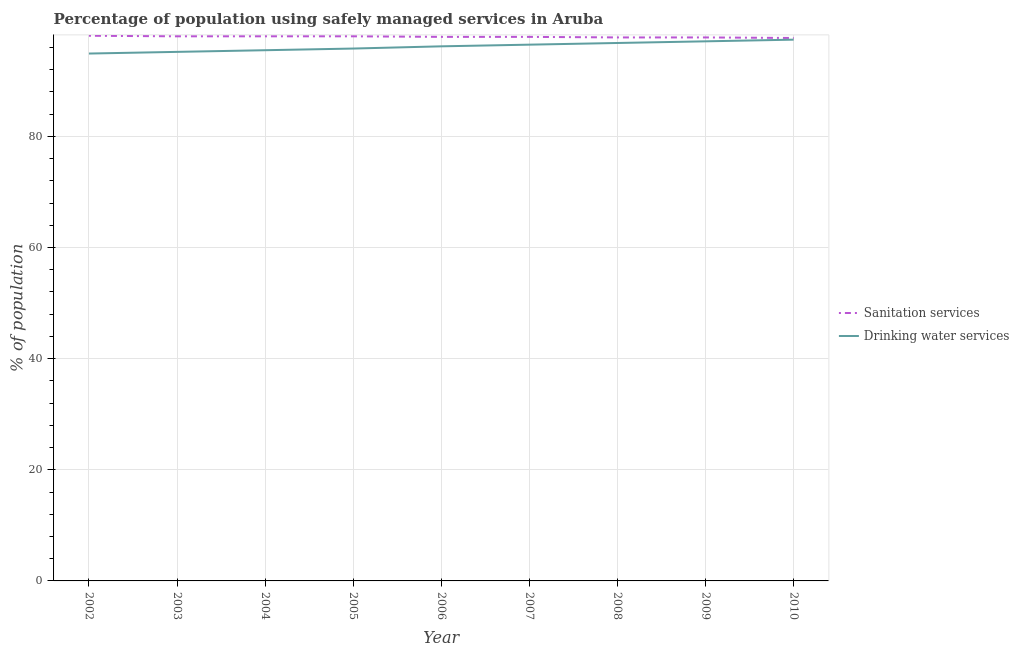How many different coloured lines are there?
Keep it short and to the point. 2. Does the line corresponding to percentage of population who used drinking water services intersect with the line corresponding to percentage of population who used sanitation services?
Your answer should be very brief. No. What is the percentage of population who used drinking water services in 2005?
Keep it short and to the point. 95.8. Across all years, what is the maximum percentage of population who used drinking water services?
Provide a succinct answer. 97.4. Across all years, what is the minimum percentage of population who used sanitation services?
Make the answer very short. 97.7. What is the total percentage of population who used sanitation services in the graph?
Your response must be concise. 881.2. What is the difference between the percentage of population who used sanitation services in 2004 and that in 2005?
Your answer should be compact. 0. What is the difference between the percentage of population who used sanitation services in 2002 and the percentage of population who used drinking water services in 2010?
Your response must be concise. 0.7. What is the average percentage of population who used drinking water services per year?
Your answer should be compact. 96.16. In the year 2007, what is the difference between the percentage of population who used drinking water services and percentage of population who used sanitation services?
Provide a succinct answer. -1.4. In how many years, is the percentage of population who used drinking water services greater than 8 %?
Your answer should be compact. 9. What is the ratio of the percentage of population who used sanitation services in 2002 to that in 2007?
Provide a succinct answer. 1. Is the percentage of population who used sanitation services in 2004 less than that in 2010?
Provide a short and direct response. No. Is the difference between the percentage of population who used drinking water services in 2003 and 2009 greater than the difference between the percentage of population who used sanitation services in 2003 and 2009?
Offer a very short reply. No. What is the difference between the highest and the second highest percentage of population who used sanitation services?
Give a very brief answer. 0.1. What is the difference between the highest and the lowest percentage of population who used drinking water services?
Provide a short and direct response. 2.5. Is the sum of the percentage of population who used drinking water services in 2005 and 2007 greater than the maximum percentage of population who used sanitation services across all years?
Offer a very short reply. Yes. Is the percentage of population who used drinking water services strictly greater than the percentage of population who used sanitation services over the years?
Provide a short and direct response. No. Is the percentage of population who used sanitation services strictly less than the percentage of population who used drinking water services over the years?
Provide a short and direct response. No. How many lines are there?
Your answer should be very brief. 2. How many years are there in the graph?
Your answer should be compact. 9. Does the graph contain grids?
Keep it short and to the point. Yes. Where does the legend appear in the graph?
Ensure brevity in your answer.  Center right. How many legend labels are there?
Your response must be concise. 2. What is the title of the graph?
Provide a short and direct response. Percentage of population using safely managed services in Aruba. Does "Urban" appear as one of the legend labels in the graph?
Give a very brief answer. No. What is the label or title of the Y-axis?
Provide a succinct answer. % of population. What is the % of population of Sanitation services in 2002?
Your answer should be compact. 98.1. What is the % of population in Drinking water services in 2002?
Your response must be concise. 94.9. What is the % of population in Sanitation services in 2003?
Give a very brief answer. 98. What is the % of population of Drinking water services in 2003?
Provide a short and direct response. 95.2. What is the % of population of Drinking water services in 2004?
Provide a succinct answer. 95.5. What is the % of population of Sanitation services in 2005?
Keep it short and to the point. 98. What is the % of population in Drinking water services in 2005?
Ensure brevity in your answer.  95.8. What is the % of population in Sanitation services in 2006?
Keep it short and to the point. 97.9. What is the % of population of Drinking water services in 2006?
Your response must be concise. 96.2. What is the % of population in Sanitation services in 2007?
Give a very brief answer. 97.9. What is the % of population of Drinking water services in 2007?
Offer a very short reply. 96.5. What is the % of population in Sanitation services in 2008?
Keep it short and to the point. 97.8. What is the % of population in Drinking water services in 2008?
Keep it short and to the point. 96.8. What is the % of population of Sanitation services in 2009?
Offer a very short reply. 97.8. What is the % of population in Drinking water services in 2009?
Offer a very short reply. 97.1. What is the % of population in Sanitation services in 2010?
Your answer should be compact. 97.7. What is the % of population of Drinking water services in 2010?
Provide a short and direct response. 97.4. Across all years, what is the maximum % of population of Sanitation services?
Give a very brief answer. 98.1. Across all years, what is the maximum % of population in Drinking water services?
Your answer should be compact. 97.4. Across all years, what is the minimum % of population of Sanitation services?
Your answer should be very brief. 97.7. Across all years, what is the minimum % of population in Drinking water services?
Keep it short and to the point. 94.9. What is the total % of population in Sanitation services in the graph?
Provide a succinct answer. 881.2. What is the total % of population of Drinking water services in the graph?
Offer a very short reply. 865.4. What is the difference between the % of population in Sanitation services in 2002 and that in 2003?
Offer a terse response. 0.1. What is the difference between the % of population of Drinking water services in 2002 and that in 2005?
Ensure brevity in your answer.  -0.9. What is the difference between the % of population of Drinking water services in 2002 and that in 2006?
Provide a succinct answer. -1.3. What is the difference between the % of population of Drinking water services in 2002 and that in 2007?
Provide a succinct answer. -1.6. What is the difference between the % of population in Sanitation services in 2002 and that in 2008?
Give a very brief answer. 0.3. What is the difference between the % of population in Drinking water services in 2002 and that in 2009?
Your answer should be compact. -2.2. What is the difference between the % of population of Drinking water services in 2002 and that in 2010?
Your answer should be very brief. -2.5. What is the difference between the % of population of Drinking water services in 2003 and that in 2006?
Provide a succinct answer. -1. What is the difference between the % of population of Sanitation services in 2003 and that in 2007?
Provide a short and direct response. 0.1. What is the difference between the % of population in Drinking water services in 2003 and that in 2007?
Your answer should be very brief. -1.3. What is the difference between the % of population in Drinking water services in 2003 and that in 2008?
Make the answer very short. -1.6. What is the difference between the % of population in Drinking water services in 2003 and that in 2009?
Your answer should be very brief. -1.9. What is the difference between the % of population of Sanitation services in 2003 and that in 2010?
Make the answer very short. 0.3. What is the difference between the % of population of Drinking water services in 2003 and that in 2010?
Ensure brevity in your answer.  -2.2. What is the difference between the % of population of Drinking water services in 2004 and that in 2006?
Offer a very short reply. -0.7. What is the difference between the % of population of Sanitation services in 2004 and that in 2007?
Provide a short and direct response. 0.1. What is the difference between the % of population in Drinking water services in 2004 and that in 2007?
Keep it short and to the point. -1. What is the difference between the % of population of Sanitation services in 2004 and that in 2008?
Offer a very short reply. 0.2. What is the difference between the % of population of Sanitation services in 2004 and that in 2009?
Give a very brief answer. 0.2. What is the difference between the % of population in Sanitation services in 2004 and that in 2010?
Offer a terse response. 0.3. What is the difference between the % of population in Drinking water services in 2005 and that in 2007?
Keep it short and to the point. -0.7. What is the difference between the % of population of Sanitation services in 2005 and that in 2009?
Give a very brief answer. 0.2. What is the difference between the % of population of Drinking water services in 2006 and that in 2007?
Offer a terse response. -0.3. What is the difference between the % of population of Sanitation services in 2006 and that in 2009?
Make the answer very short. 0.1. What is the difference between the % of population in Drinking water services in 2006 and that in 2009?
Your response must be concise. -0.9. What is the difference between the % of population in Sanitation services in 2007 and that in 2008?
Keep it short and to the point. 0.1. What is the difference between the % of population of Sanitation services in 2007 and that in 2010?
Your response must be concise. 0.2. What is the difference between the % of population of Sanitation services in 2008 and that in 2010?
Your answer should be compact. 0.1. What is the difference between the % of population of Drinking water services in 2008 and that in 2010?
Offer a terse response. -0.6. What is the difference between the % of population of Sanitation services in 2002 and the % of population of Drinking water services in 2006?
Give a very brief answer. 1.9. What is the difference between the % of population in Sanitation services in 2002 and the % of population in Drinking water services in 2007?
Offer a terse response. 1.6. What is the difference between the % of population of Sanitation services in 2002 and the % of population of Drinking water services in 2008?
Offer a terse response. 1.3. What is the difference between the % of population of Sanitation services in 2002 and the % of population of Drinking water services in 2009?
Your answer should be compact. 1. What is the difference between the % of population of Sanitation services in 2002 and the % of population of Drinking water services in 2010?
Ensure brevity in your answer.  0.7. What is the difference between the % of population in Sanitation services in 2003 and the % of population in Drinking water services in 2004?
Your answer should be very brief. 2.5. What is the difference between the % of population of Sanitation services in 2003 and the % of population of Drinking water services in 2005?
Offer a very short reply. 2.2. What is the difference between the % of population in Sanitation services in 2003 and the % of population in Drinking water services in 2006?
Your response must be concise. 1.8. What is the difference between the % of population of Sanitation services in 2003 and the % of population of Drinking water services in 2009?
Your answer should be compact. 0.9. What is the difference between the % of population in Sanitation services in 2003 and the % of population in Drinking water services in 2010?
Your answer should be very brief. 0.6. What is the difference between the % of population of Sanitation services in 2004 and the % of population of Drinking water services in 2006?
Provide a short and direct response. 1.8. What is the difference between the % of population in Sanitation services in 2004 and the % of population in Drinking water services in 2009?
Give a very brief answer. 0.9. What is the difference between the % of population in Sanitation services in 2005 and the % of population in Drinking water services in 2006?
Make the answer very short. 1.8. What is the difference between the % of population in Sanitation services in 2005 and the % of population in Drinking water services in 2008?
Provide a succinct answer. 1.2. What is the difference between the % of population in Sanitation services in 2006 and the % of population in Drinking water services in 2007?
Give a very brief answer. 1.4. What is the difference between the % of population of Sanitation services in 2006 and the % of population of Drinking water services in 2008?
Your answer should be compact. 1.1. What is the difference between the % of population of Sanitation services in 2006 and the % of population of Drinking water services in 2010?
Provide a succinct answer. 0.5. What is the difference between the % of population of Sanitation services in 2007 and the % of population of Drinking water services in 2008?
Ensure brevity in your answer.  1.1. What is the difference between the % of population of Sanitation services in 2007 and the % of population of Drinking water services in 2009?
Ensure brevity in your answer.  0.8. What is the difference between the % of population in Sanitation services in 2008 and the % of population in Drinking water services in 2009?
Provide a succinct answer. 0.7. What is the difference between the % of population in Sanitation services in 2009 and the % of population in Drinking water services in 2010?
Provide a succinct answer. 0.4. What is the average % of population of Sanitation services per year?
Offer a terse response. 97.91. What is the average % of population in Drinking water services per year?
Provide a short and direct response. 96.16. In the year 2006, what is the difference between the % of population of Sanitation services and % of population of Drinking water services?
Provide a short and direct response. 1.7. In the year 2007, what is the difference between the % of population in Sanitation services and % of population in Drinking water services?
Offer a terse response. 1.4. In the year 2009, what is the difference between the % of population of Sanitation services and % of population of Drinking water services?
Ensure brevity in your answer.  0.7. In the year 2010, what is the difference between the % of population of Sanitation services and % of population of Drinking water services?
Your answer should be compact. 0.3. What is the ratio of the % of population of Sanitation services in 2002 to that in 2005?
Keep it short and to the point. 1. What is the ratio of the % of population in Drinking water services in 2002 to that in 2005?
Offer a terse response. 0.99. What is the ratio of the % of population of Sanitation services in 2002 to that in 2006?
Provide a short and direct response. 1. What is the ratio of the % of population of Drinking water services in 2002 to that in 2006?
Ensure brevity in your answer.  0.99. What is the ratio of the % of population in Sanitation services in 2002 to that in 2007?
Ensure brevity in your answer.  1. What is the ratio of the % of population of Drinking water services in 2002 to that in 2007?
Your response must be concise. 0.98. What is the ratio of the % of population in Drinking water services in 2002 to that in 2008?
Give a very brief answer. 0.98. What is the ratio of the % of population in Sanitation services in 2002 to that in 2009?
Your response must be concise. 1. What is the ratio of the % of population of Drinking water services in 2002 to that in 2009?
Your answer should be compact. 0.98. What is the ratio of the % of population of Sanitation services in 2002 to that in 2010?
Keep it short and to the point. 1. What is the ratio of the % of population of Drinking water services in 2002 to that in 2010?
Ensure brevity in your answer.  0.97. What is the ratio of the % of population of Sanitation services in 2003 to that in 2005?
Ensure brevity in your answer.  1. What is the ratio of the % of population of Drinking water services in 2003 to that in 2005?
Provide a short and direct response. 0.99. What is the ratio of the % of population in Drinking water services in 2003 to that in 2007?
Provide a succinct answer. 0.99. What is the ratio of the % of population of Sanitation services in 2003 to that in 2008?
Your answer should be very brief. 1. What is the ratio of the % of population in Drinking water services in 2003 to that in 2008?
Keep it short and to the point. 0.98. What is the ratio of the % of population in Sanitation services in 2003 to that in 2009?
Provide a short and direct response. 1. What is the ratio of the % of population of Drinking water services in 2003 to that in 2009?
Ensure brevity in your answer.  0.98. What is the ratio of the % of population of Sanitation services in 2003 to that in 2010?
Give a very brief answer. 1. What is the ratio of the % of population of Drinking water services in 2003 to that in 2010?
Provide a short and direct response. 0.98. What is the ratio of the % of population in Drinking water services in 2004 to that in 2005?
Make the answer very short. 1. What is the ratio of the % of population in Sanitation services in 2004 to that in 2006?
Your answer should be very brief. 1. What is the ratio of the % of population of Drinking water services in 2004 to that in 2006?
Give a very brief answer. 0.99. What is the ratio of the % of population in Drinking water services in 2004 to that in 2007?
Your answer should be very brief. 0.99. What is the ratio of the % of population in Sanitation services in 2004 to that in 2008?
Your response must be concise. 1. What is the ratio of the % of population in Drinking water services in 2004 to that in 2008?
Your response must be concise. 0.99. What is the ratio of the % of population in Sanitation services in 2004 to that in 2009?
Provide a short and direct response. 1. What is the ratio of the % of population of Drinking water services in 2004 to that in 2009?
Your answer should be compact. 0.98. What is the ratio of the % of population of Drinking water services in 2004 to that in 2010?
Make the answer very short. 0.98. What is the ratio of the % of population in Drinking water services in 2005 to that in 2006?
Make the answer very short. 1. What is the ratio of the % of population of Sanitation services in 2005 to that in 2007?
Your answer should be compact. 1. What is the ratio of the % of population in Drinking water services in 2005 to that in 2007?
Provide a short and direct response. 0.99. What is the ratio of the % of population of Sanitation services in 2005 to that in 2008?
Your answer should be compact. 1. What is the ratio of the % of population in Drinking water services in 2005 to that in 2008?
Provide a succinct answer. 0.99. What is the ratio of the % of population in Drinking water services in 2005 to that in 2009?
Give a very brief answer. 0.99. What is the ratio of the % of population in Drinking water services in 2005 to that in 2010?
Provide a short and direct response. 0.98. What is the ratio of the % of population of Sanitation services in 2006 to that in 2007?
Give a very brief answer. 1. What is the ratio of the % of population in Sanitation services in 2006 to that in 2008?
Offer a very short reply. 1. What is the ratio of the % of population of Sanitation services in 2006 to that in 2010?
Give a very brief answer. 1. What is the ratio of the % of population of Sanitation services in 2007 to that in 2008?
Offer a terse response. 1. What is the ratio of the % of population of Drinking water services in 2007 to that in 2010?
Offer a very short reply. 0.99. What is the ratio of the % of population of Drinking water services in 2008 to that in 2009?
Keep it short and to the point. 1. What is the ratio of the % of population of Sanitation services in 2008 to that in 2010?
Ensure brevity in your answer.  1. What is the difference between the highest and the second highest % of population of Sanitation services?
Keep it short and to the point. 0.1. What is the difference between the highest and the lowest % of population in Drinking water services?
Your answer should be very brief. 2.5. 